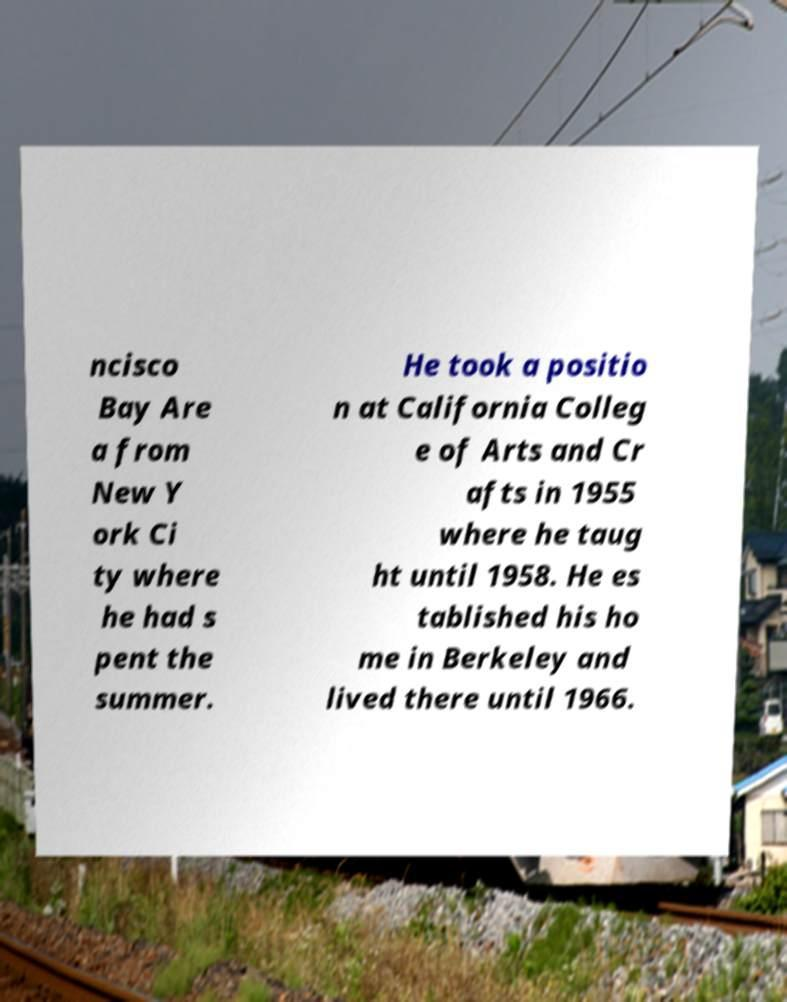I need the written content from this picture converted into text. Can you do that? ncisco Bay Are a from New Y ork Ci ty where he had s pent the summer. He took a positio n at California Colleg e of Arts and Cr afts in 1955 where he taug ht until 1958. He es tablished his ho me in Berkeley and lived there until 1966. 